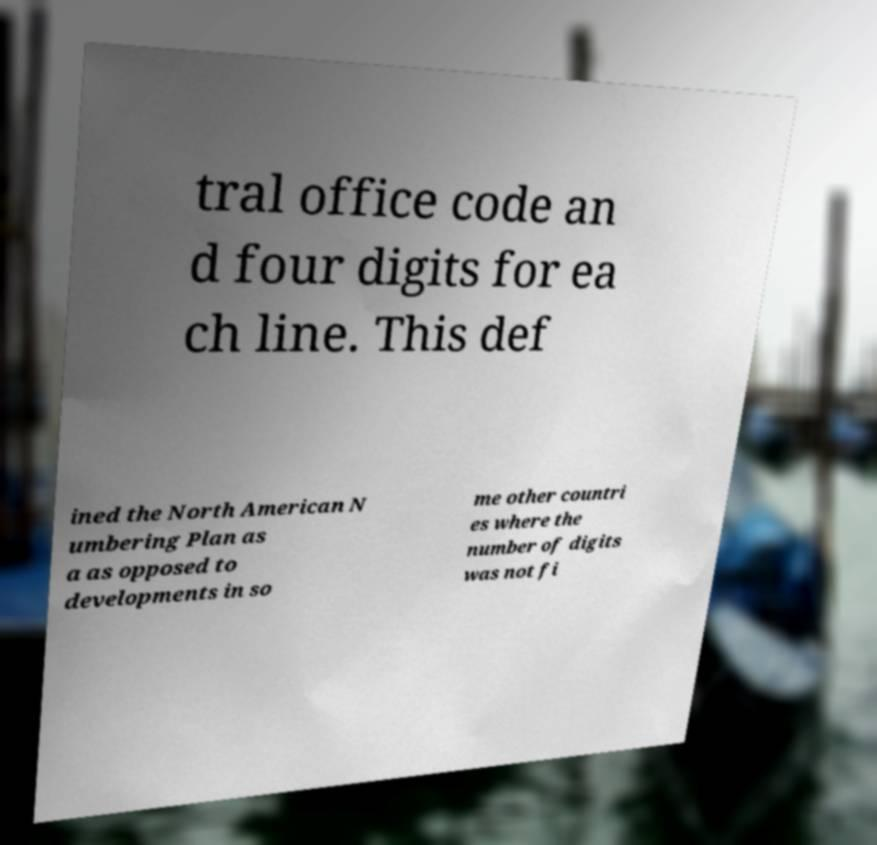There's text embedded in this image that I need extracted. Can you transcribe it verbatim? tral office code an d four digits for ea ch line. This def ined the North American N umbering Plan as a as opposed to developments in so me other countri es where the number of digits was not fi 